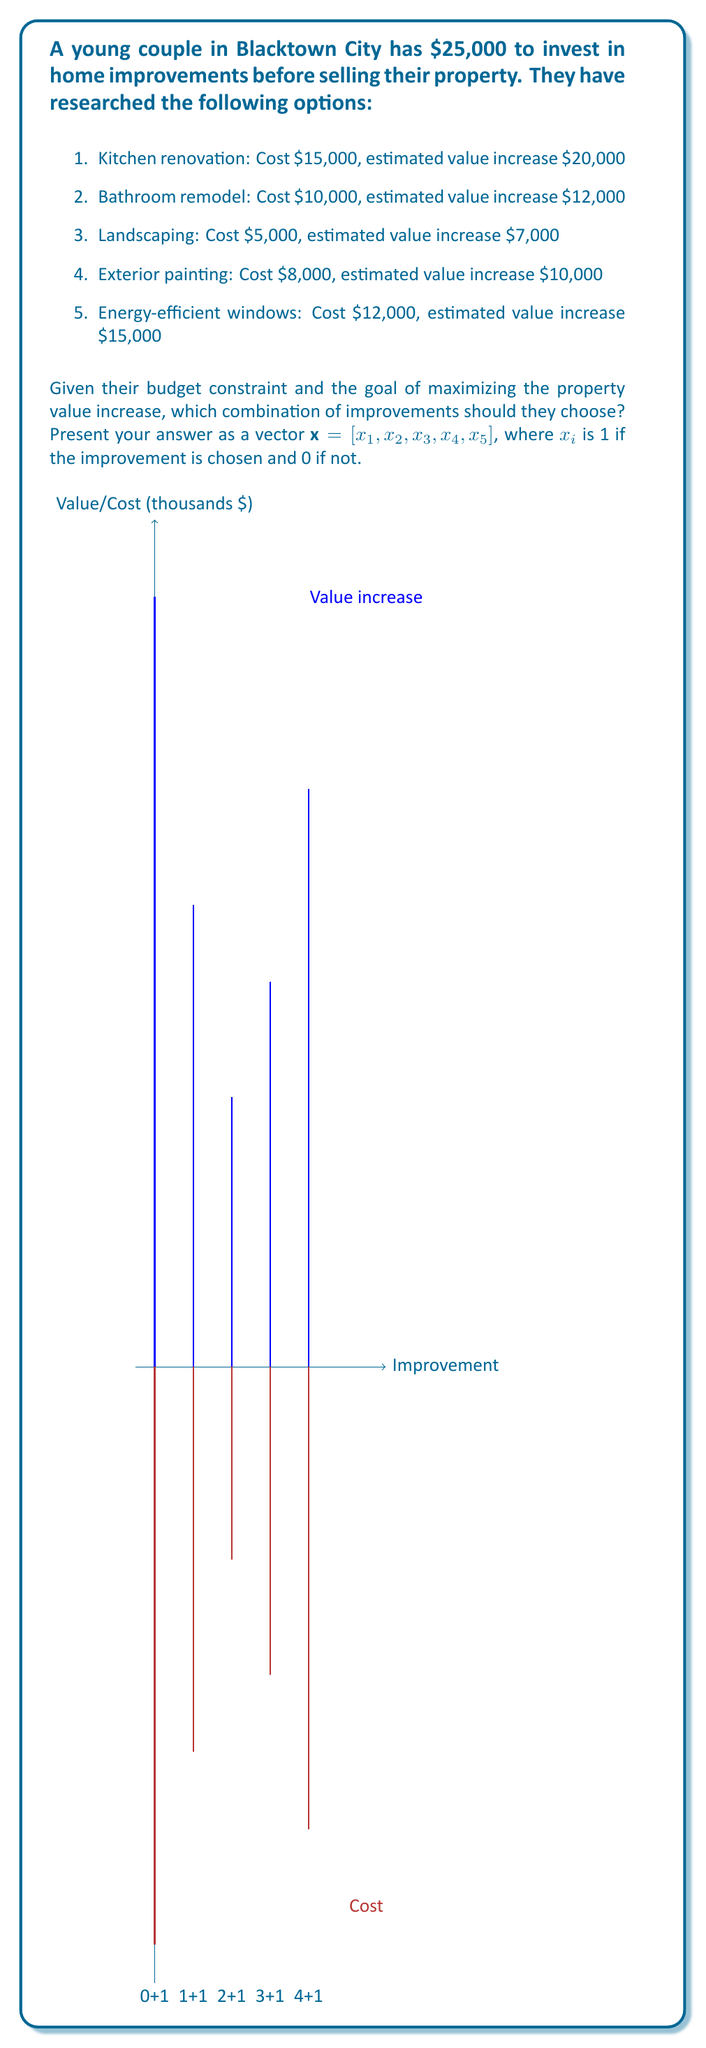Solve this math problem. To solve this optimization problem, we can use the 0-1 Knapsack algorithm. Let's approach this step-by-step:

1) First, let's define our variables:
   $x_i = 1$ if improvement $i$ is chosen, 0 otherwise
   $c_i$ = cost of improvement $i$
   $v_i$ = value increase of improvement $i$

2) Our objective function is to maximize the total value increase:
   $$\text{Maximize} \sum_{i=1}^5 v_i x_i$$

3) Subject to the budget constraint:
   $$\sum_{i=1}^5 c_i x_i \leq 25000$$

4) Let's calculate the value-to-cost ratio for each improvement:
   Kitchen: $20000/15000 = 1.33$
   Bathroom: $12000/10000 = 1.20$
   Landscaping: $7000/5000 = 1.40$
   Exterior painting: $10000/8000 = 1.25$
   Windows: $15000/12000 = 1.25$

5) We sort the improvements by their value-to-cost ratio in descending order:
   Landscaping, Kitchen, Exterior painting, Windows, Bathroom

6) Now, we start selecting improvements in this order until we can't add any more:
   Landscaping: Cost $5000, Budget left $20000
   Kitchen: Cost $15000, Budget left $5000
   We can't add any more improvements with the remaining $5000

7) Therefore, our solution is:
   $x = [1, 0, 1, 0, 0]$

This combination gives a total value increase of $20000 + $7000 = $27000, with a total cost of $20000.
Answer: $x = [1, 0, 1, 0, 0]$ 